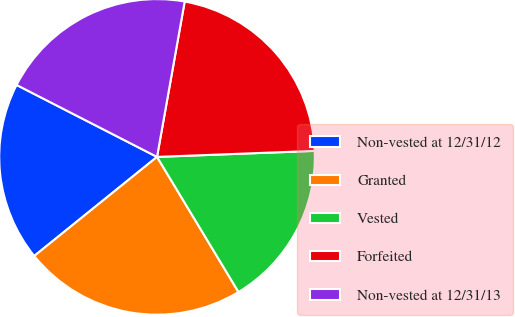<chart> <loc_0><loc_0><loc_500><loc_500><pie_chart><fcel>Non-vested at 12/31/12<fcel>Granted<fcel>Vested<fcel>Forfeited<fcel>Non-vested at 12/31/13<nl><fcel>18.34%<fcel>22.83%<fcel>16.97%<fcel>21.59%<fcel>20.27%<nl></chart> 